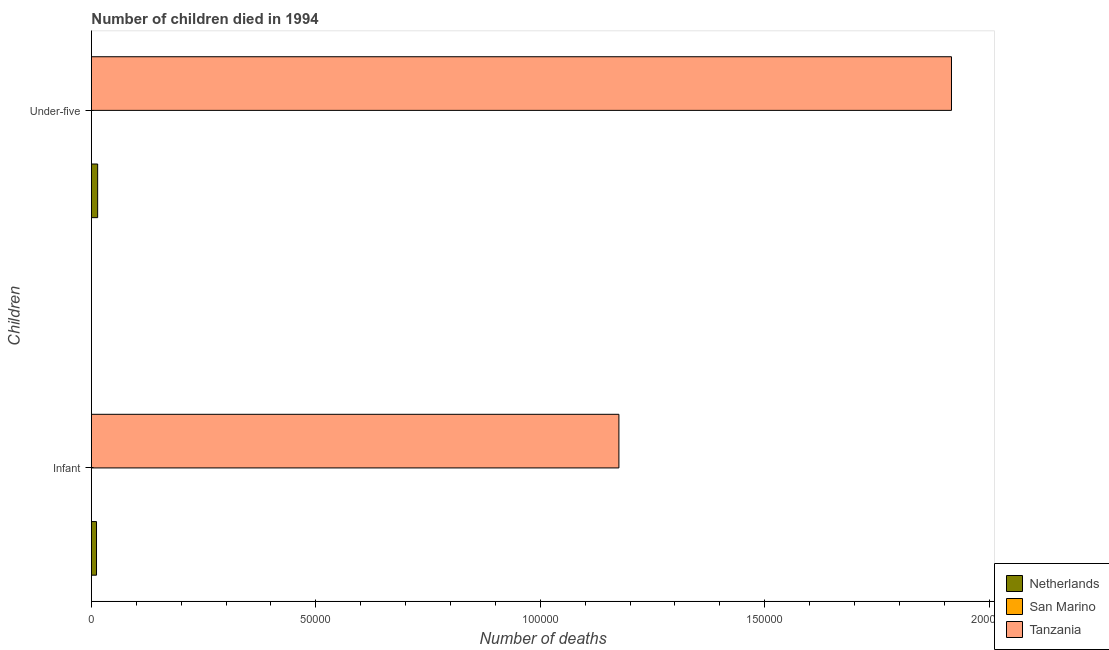How many different coloured bars are there?
Your answer should be very brief. 3. How many groups of bars are there?
Provide a short and direct response. 2. Are the number of bars on each tick of the Y-axis equal?
Your answer should be compact. Yes. How many bars are there on the 1st tick from the bottom?
Offer a very short reply. 3. What is the label of the 2nd group of bars from the top?
Your response must be concise. Infant. What is the number of infant deaths in Tanzania?
Ensure brevity in your answer.  1.18e+05. Across all countries, what is the maximum number of infant deaths?
Your answer should be very brief. 1.18e+05. Across all countries, what is the minimum number of infant deaths?
Provide a short and direct response. 3. In which country was the number of infant deaths maximum?
Give a very brief answer. Tanzania. In which country was the number of infant deaths minimum?
Provide a succinct answer. San Marino. What is the total number of infant deaths in the graph?
Provide a succinct answer. 1.19e+05. What is the difference between the number of under-five deaths in Tanzania and that in Netherlands?
Your answer should be very brief. 1.90e+05. What is the difference between the number of infant deaths in Tanzania and the number of under-five deaths in San Marino?
Provide a short and direct response. 1.18e+05. What is the average number of under-five deaths per country?
Provide a short and direct response. 6.43e+04. What is the difference between the number of infant deaths and number of under-five deaths in Tanzania?
Give a very brief answer. -7.41e+04. What is the ratio of the number of infant deaths in San Marino to that in Tanzania?
Ensure brevity in your answer.  2.5529959407364544e-5. Is the number of infant deaths in San Marino less than that in Netherlands?
Offer a very short reply. Yes. What does the 1st bar from the top in Under-five represents?
Your answer should be very brief. Tanzania. What is the difference between two consecutive major ticks on the X-axis?
Your answer should be compact. 5.00e+04. Are the values on the major ticks of X-axis written in scientific E-notation?
Keep it short and to the point. No. Does the graph contain any zero values?
Make the answer very short. No. Does the graph contain grids?
Give a very brief answer. No. Where does the legend appear in the graph?
Offer a very short reply. Bottom right. How are the legend labels stacked?
Provide a succinct answer. Vertical. What is the title of the graph?
Provide a short and direct response. Number of children died in 1994. Does "World" appear as one of the legend labels in the graph?
Make the answer very short. No. What is the label or title of the X-axis?
Your answer should be compact. Number of deaths. What is the label or title of the Y-axis?
Your answer should be very brief. Children. What is the Number of deaths of Netherlands in Infant?
Keep it short and to the point. 1133. What is the Number of deaths in San Marino in Infant?
Your answer should be very brief. 3. What is the Number of deaths in Tanzania in Infant?
Offer a very short reply. 1.18e+05. What is the Number of deaths in Netherlands in Under-five?
Your answer should be compact. 1388. What is the Number of deaths in San Marino in Under-five?
Provide a short and direct response. 3. What is the Number of deaths of Tanzania in Under-five?
Your response must be concise. 1.92e+05. Across all Children, what is the maximum Number of deaths of Netherlands?
Your answer should be very brief. 1388. Across all Children, what is the maximum Number of deaths of Tanzania?
Your answer should be very brief. 1.92e+05. Across all Children, what is the minimum Number of deaths of Netherlands?
Your answer should be very brief. 1133. Across all Children, what is the minimum Number of deaths in Tanzania?
Keep it short and to the point. 1.18e+05. What is the total Number of deaths in Netherlands in the graph?
Your answer should be very brief. 2521. What is the total Number of deaths of Tanzania in the graph?
Keep it short and to the point. 3.09e+05. What is the difference between the Number of deaths of Netherlands in Infant and that in Under-five?
Your response must be concise. -255. What is the difference between the Number of deaths in Tanzania in Infant and that in Under-five?
Your answer should be compact. -7.41e+04. What is the difference between the Number of deaths of Netherlands in Infant and the Number of deaths of San Marino in Under-five?
Your answer should be compact. 1130. What is the difference between the Number of deaths in Netherlands in Infant and the Number of deaths in Tanzania in Under-five?
Ensure brevity in your answer.  -1.90e+05. What is the difference between the Number of deaths of San Marino in Infant and the Number of deaths of Tanzania in Under-five?
Offer a terse response. -1.92e+05. What is the average Number of deaths of Netherlands per Children?
Offer a terse response. 1260.5. What is the average Number of deaths in San Marino per Children?
Your response must be concise. 3. What is the average Number of deaths of Tanzania per Children?
Ensure brevity in your answer.  1.55e+05. What is the difference between the Number of deaths of Netherlands and Number of deaths of San Marino in Infant?
Provide a succinct answer. 1130. What is the difference between the Number of deaths in Netherlands and Number of deaths in Tanzania in Infant?
Give a very brief answer. -1.16e+05. What is the difference between the Number of deaths of San Marino and Number of deaths of Tanzania in Infant?
Your response must be concise. -1.18e+05. What is the difference between the Number of deaths in Netherlands and Number of deaths in San Marino in Under-five?
Ensure brevity in your answer.  1385. What is the difference between the Number of deaths of Netherlands and Number of deaths of Tanzania in Under-five?
Keep it short and to the point. -1.90e+05. What is the difference between the Number of deaths of San Marino and Number of deaths of Tanzania in Under-five?
Provide a short and direct response. -1.92e+05. What is the ratio of the Number of deaths of Netherlands in Infant to that in Under-five?
Offer a terse response. 0.82. What is the ratio of the Number of deaths in Tanzania in Infant to that in Under-five?
Provide a short and direct response. 0.61. What is the difference between the highest and the second highest Number of deaths in Netherlands?
Your response must be concise. 255. What is the difference between the highest and the second highest Number of deaths in San Marino?
Your answer should be compact. 0. What is the difference between the highest and the second highest Number of deaths in Tanzania?
Provide a short and direct response. 7.41e+04. What is the difference between the highest and the lowest Number of deaths in Netherlands?
Provide a succinct answer. 255. What is the difference between the highest and the lowest Number of deaths in Tanzania?
Provide a short and direct response. 7.41e+04. 